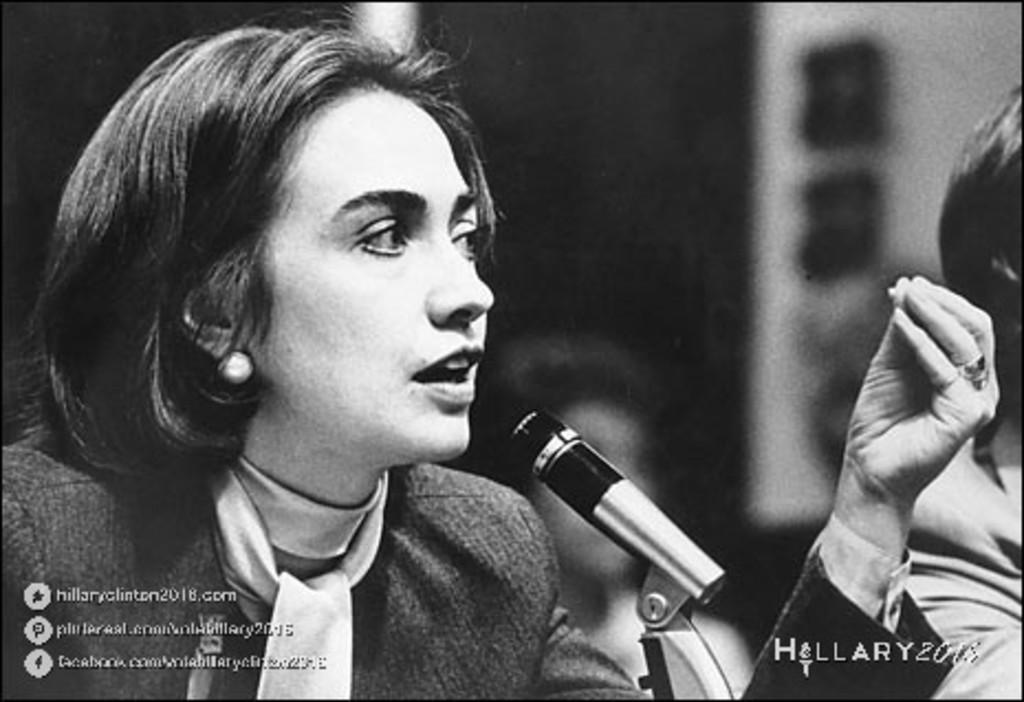Who is the main subject in the image? There is a woman in the image. What is the woman doing in the image? The woman is sitting on a chair. What is the woman wearing in the image? The woman is wearing a scarf around her neck. What object is present in the image that is typically used for amplifying sound? There is a microphone with a stand in the image. What color scheme is used in the image? The image is in black and white color. How many ducks are visible in the image? There are no ducks present in the image. What type of vacation is the woman planning based on the image? There is no information in the image to suggest that the woman is planning a vacation. 